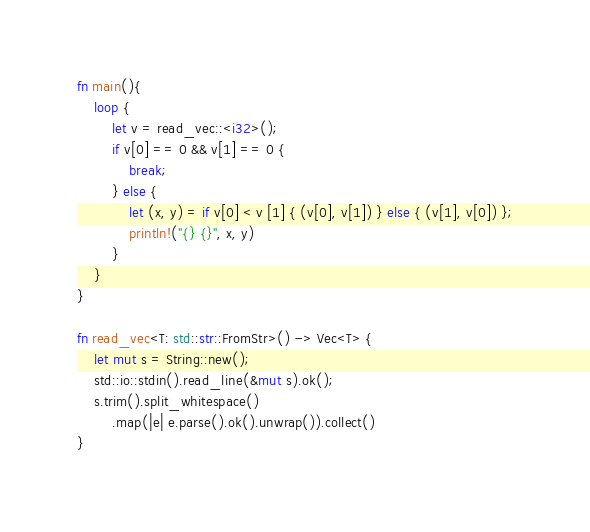Convert code to text. <code><loc_0><loc_0><loc_500><loc_500><_Rust_>fn main(){
	loop {
		let v = read_vec::<i32>();
		if v[0] == 0 && v[1] == 0 {
			break;
		} else {
	        let (x, y) = if v[0] < v [1] { (v[0], v[1]) } else { (v[1], v[0]) };
	        println!("{} {}", x, y)
	    }
	}
}
 
fn read_vec<T: std::str::FromStr>() -> Vec<T> {
    let mut s = String::new();
    std::io::stdin().read_line(&mut s).ok();
    s.trim().split_whitespace()
        .map(|e| e.parse().ok().unwrap()).collect()
}
</code> 